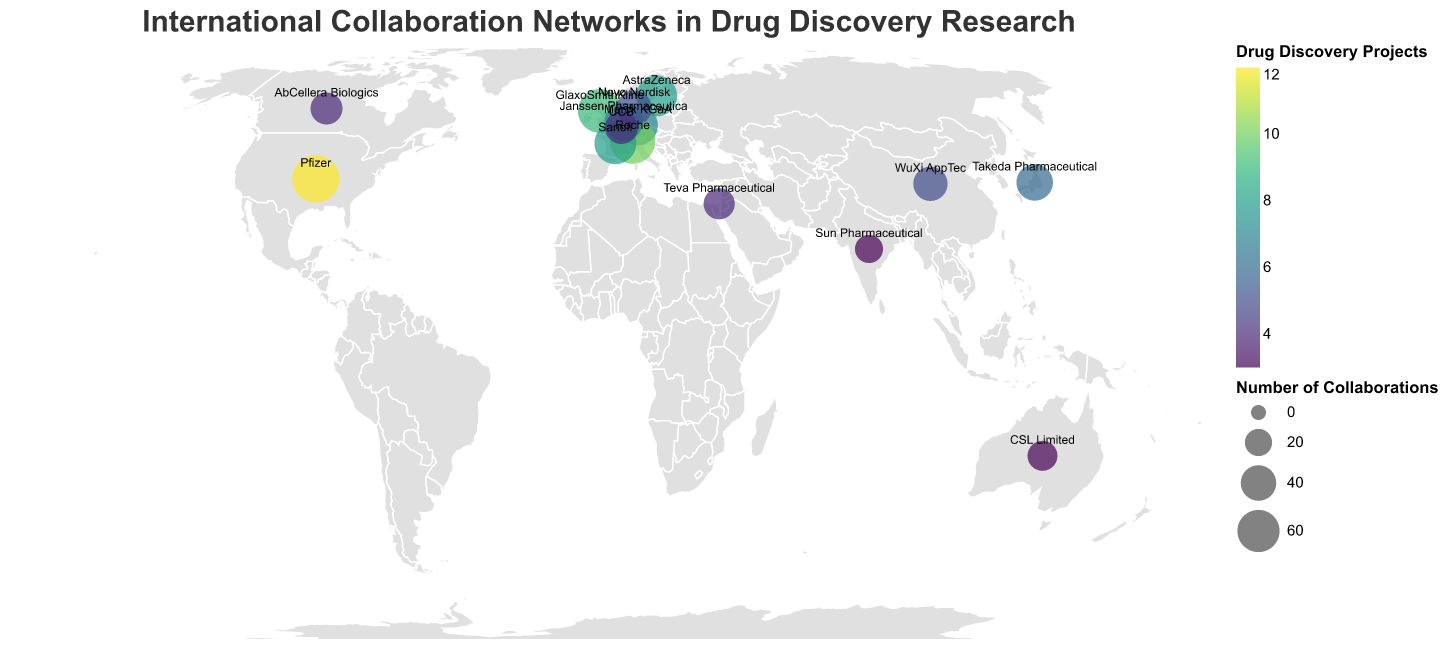Which institution has the highest number of collaborations? By examining the sizes of the circles on the map, the largest circle represents Pfizer in the USA, which indicates the highest number of collaborations.
Answer: Pfizer What is the total number of drug discovery projects among all institutions? Summing up drug discovery projects for all institutions: 12 (Pfizer) + 9 (GlaxoSmithKline) + 7 (Merck KGaA) + 6 (Takeda Pharmaceutical) + 10 (Roche) + 8 (Sanofi) + 5 (WuXi AppTec) + 7 (Janssen Pharmaceutica) + 4 (AbCellera Biologics) + 3 (CSL Limited) + 3 (Sun Pharmaceutical) + 8 (AstraZeneca) + 5 (Novo Nordisk) + 4 (UCB) + 4 (Teva Pharmaceutical) = 95
Answer: 95 Among Swiss and German institutions, which has more drug discovery projects? Looking at the map, Roche in Switzerland has 10 drug discovery projects, while Merck KGaA in Germany has 7. Thus, Roche has more drug discovery projects.
Answer: Roche How many collaborations does Takeda Pharmaceutical have? By finding the corresponding circle for Takeda Pharmaceutical in Japan, the number of collaborations shown is 43.
Answer: 43 What is the ratio of collaborations to drug discovery projects for Sun Pharmaceutical? For Sun Pharmaceutical, number of collaborations is 22 and drug discovery projects is 3. The ratio is 22/3.
Answer: 22/3 Which institution focuses on AI-driven drug design and how many collaborations do they have? WuXi AppTec in China focuses on AI-driven drug design and has 37 collaborations.
Answer: WuXi AppTec, 37 What is the key research area for the institution with the most drug discovery projects? Examining the circles, Pfizer has the most drug discovery projects with 12. Pfizer's key research area is Small molecule inhibitors.
Answer: Small molecule inhibitors Compare the number of collaborations of institutions in France and Denmark. Which one has more? Sanofi in France has 59 collaborations, while Novo Nordisk in Denmark has 39. Sanofi has more collaborations.
Answer: Sanofi How many institutions have more than 50 collaborations? The institutions with more than 50 collaborations are Pfizer (78), GlaxoSmithKline (65), Merck KGaA (52), Roche (71), and AstraZeneca (56). Count equals to 5.
Answer: 5 What are the names of institutions located in Europe with over 50 collaborations? Examining circles in Europe, the institutions with more than 50 collaborations are GlaxoSmithKline in the UK, Merck KGaA in Germany, Roche in Switzerland, and AstraZeneca in Sweden.
Answer: GlaxoSmithKline, Merck KGaA, Roche, AstraZeneca 